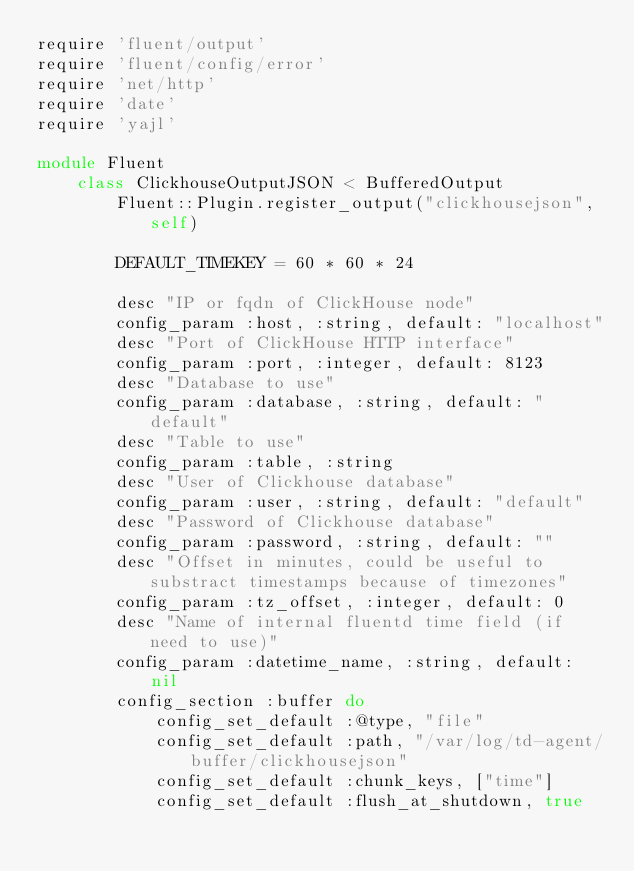Convert code to text. <code><loc_0><loc_0><loc_500><loc_500><_Ruby_>require 'fluent/output'
require 'fluent/config/error'
require 'net/http'
require 'date'
require 'yajl'

module Fluent
    class ClickhouseOutputJSON < BufferedOutput
        Fluent::Plugin.register_output("clickhousejson", self)

        DEFAULT_TIMEKEY = 60 * 60 * 24

        desc "IP or fqdn of ClickHouse node"
        config_param :host, :string, default: "localhost"
        desc "Port of ClickHouse HTTP interface"
        config_param :port, :integer, default: 8123
        desc "Database to use"
        config_param :database, :string, default: "default"
        desc "Table to use"
        config_param :table, :string
        desc "User of Clickhouse database"
        config_param :user, :string, default: "default"
        desc "Password of Clickhouse database"
        config_param :password, :string, default: ""
        desc "Offset in minutes, could be useful to substract timestamps because of timezones"
        config_param :tz_offset, :integer, default: 0
        desc "Name of internal fluentd time field (if need to use)"
        config_param :datetime_name, :string, default: nil
        config_section :buffer do
            config_set_default :@type, "file"
            config_set_default :path, "/var/log/td-agent/buffer/clickhousejson"
            config_set_default :chunk_keys, ["time"]
            config_set_default :flush_at_shutdown, true</code> 